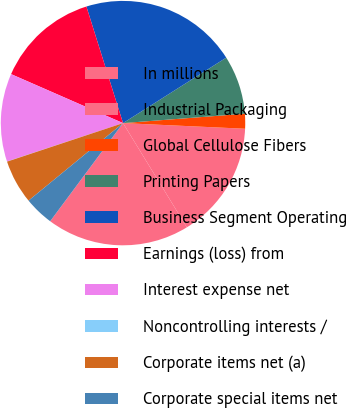<chart> <loc_0><loc_0><loc_500><loc_500><pie_chart><fcel>In millions<fcel>Industrial Packaging<fcel>Global Cellulose Fibers<fcel>Printing Papers<fcel>Business Segment Operating<fcel>Earnings (loss) from<fcel>Interest expense net<fcel>Noncontrolling interests /<fcel>Corporate items net (a)<fcel>Corporate special items net<nl><fcel>18.91%<fcel>15.52%<fcel>1.96%<fcel>7.77%<fcel>20.85%<fcel>13.59%<fcel>11.65%<fcel>0.02%<fcel>5.83%<fcel>3.9%<nl></chart> 